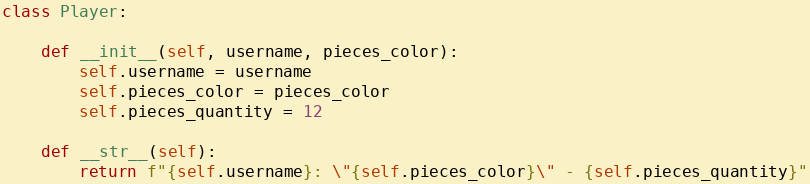<code> <loc_0><loc_0><loc_500><loc_500><_Python_>

class Player:

    def __init__(self, username, pieces_color):
        self.username = username
        self.pieces_color = pieces_color
        self.pieces_quantity = 12

    def __str__(self):
        return f"{self.username}: \"{self.pieces_color}\" - {self.pieces_quantity}"



</code> 